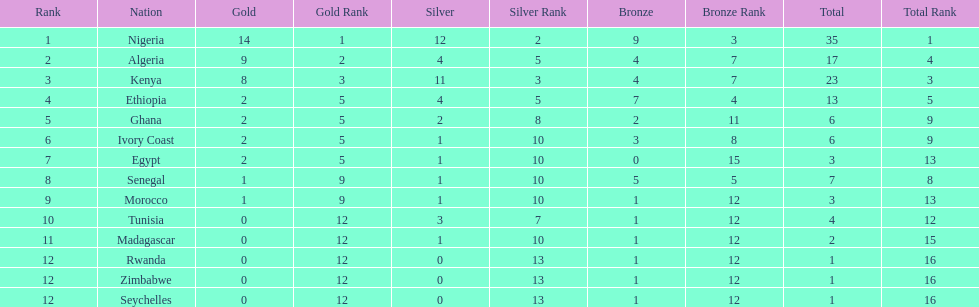How many silver medals did kenya earn? 11. 